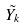Convert formula to latex. <formula><loc_0><loc_0><loc_500><loc_500>\tilde { Y _ { k } }</formula> 